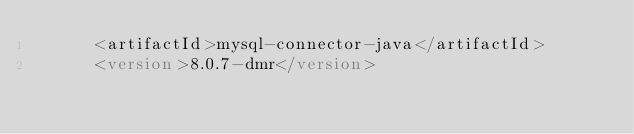<code> <loc_0><loc_0><loc_500><loc_500><_XML_>      <artifactId>mysql-connector-java</artifactId>
      <version>8.0.7-dmr</version></code> 